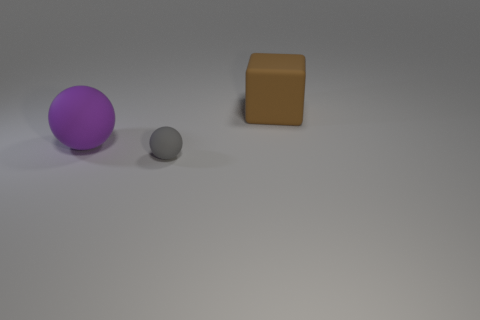What is the size of the gray sphere that is the same material as the large brown object?
Your answer should be compact. Small. There is a large thing that is in front of the big object that is right of the rubber thing in front of the large purple sphere; what color is it?
Offer a very short reply. Purple. What is the shape of the large brown thing?
Provide a short and direct response. Cube. Are there an equal number of small gray matte spheres that are to the right of the large cube and green cylinders?
Your response must be concise. Yes. How many purple rubber spheres have the same size as the matte block?
Your response must be concise. 1. Is there a large brown matte cylinder?
Provide a short and direct response. No. Do the large object that is in front of the big brown object and the object that is in front of the big purple sphere have the same shape?
Ensure brevity in your answer.  Yes. What number of large objects are either brown metal cylinders or purple things?
Provide a short and direct response. 1. What shape is the purple object that is the same material as the gray object?
Your answer should be very brief. Sphere. Do the big purple matte object and the gray rubber thing have the same shape?
Keep it short and to the point. Yes. 